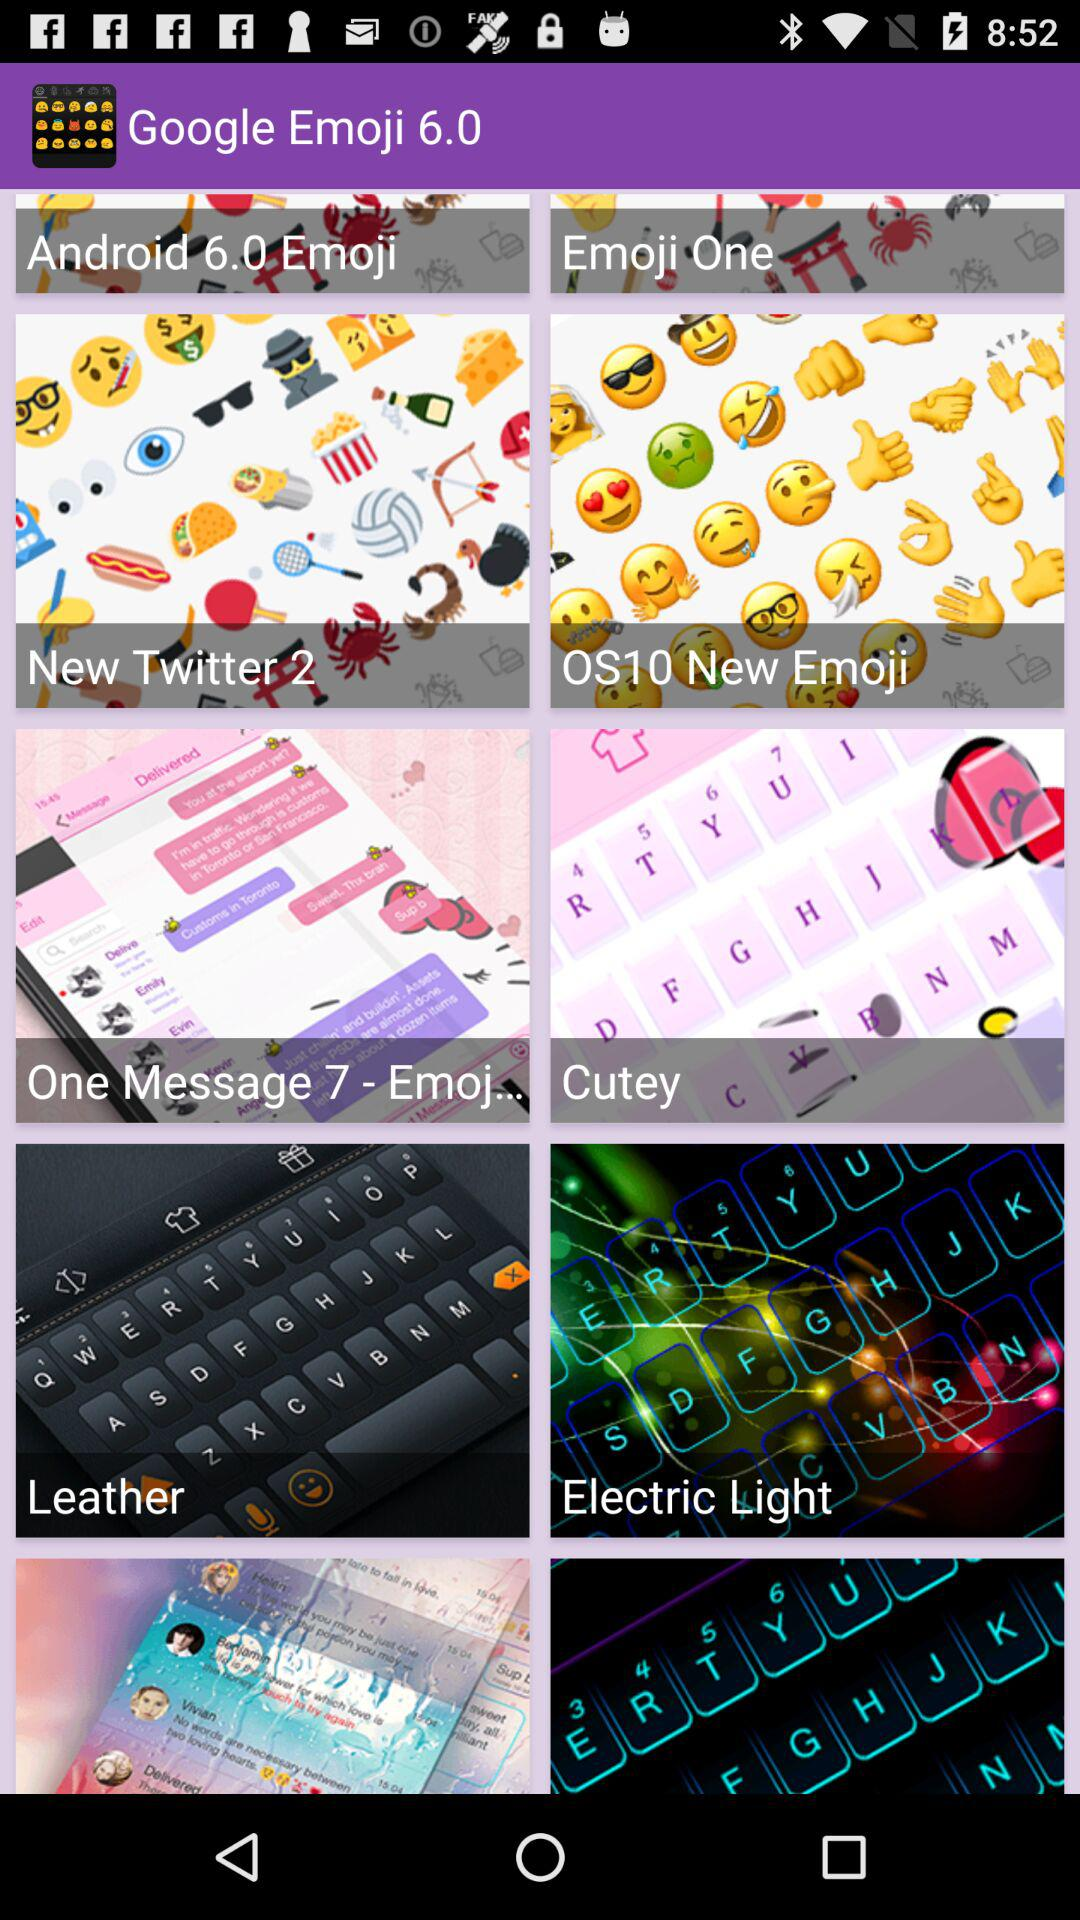What is the version of Google Emoji?
When the provided information is insufficient, respond with <no answer>. <no answer> 